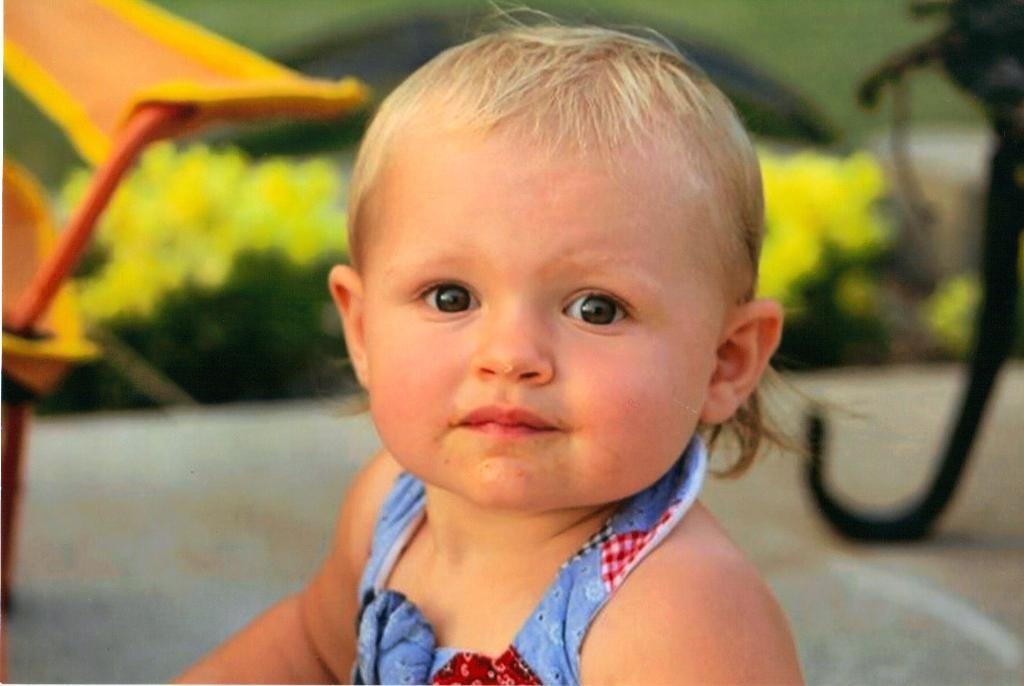What is the main subject of the image? There is a baby in the image. What is the baby doing in the image? The baby is watching something. Can you describe the background of the image? The background of the image has a blurred view. What type of natural elements can be seen in the image? There are plants visible in the image. What else can be seen on the surface in the image? There are objects on the surface in the image. What type of sail can be seen in the image? There is no sail present in the image. Is there a stranger interacting with the baby in the image? There is no stranger present in the image; the baby is watching something, but it is not specified who or what they are watching. 